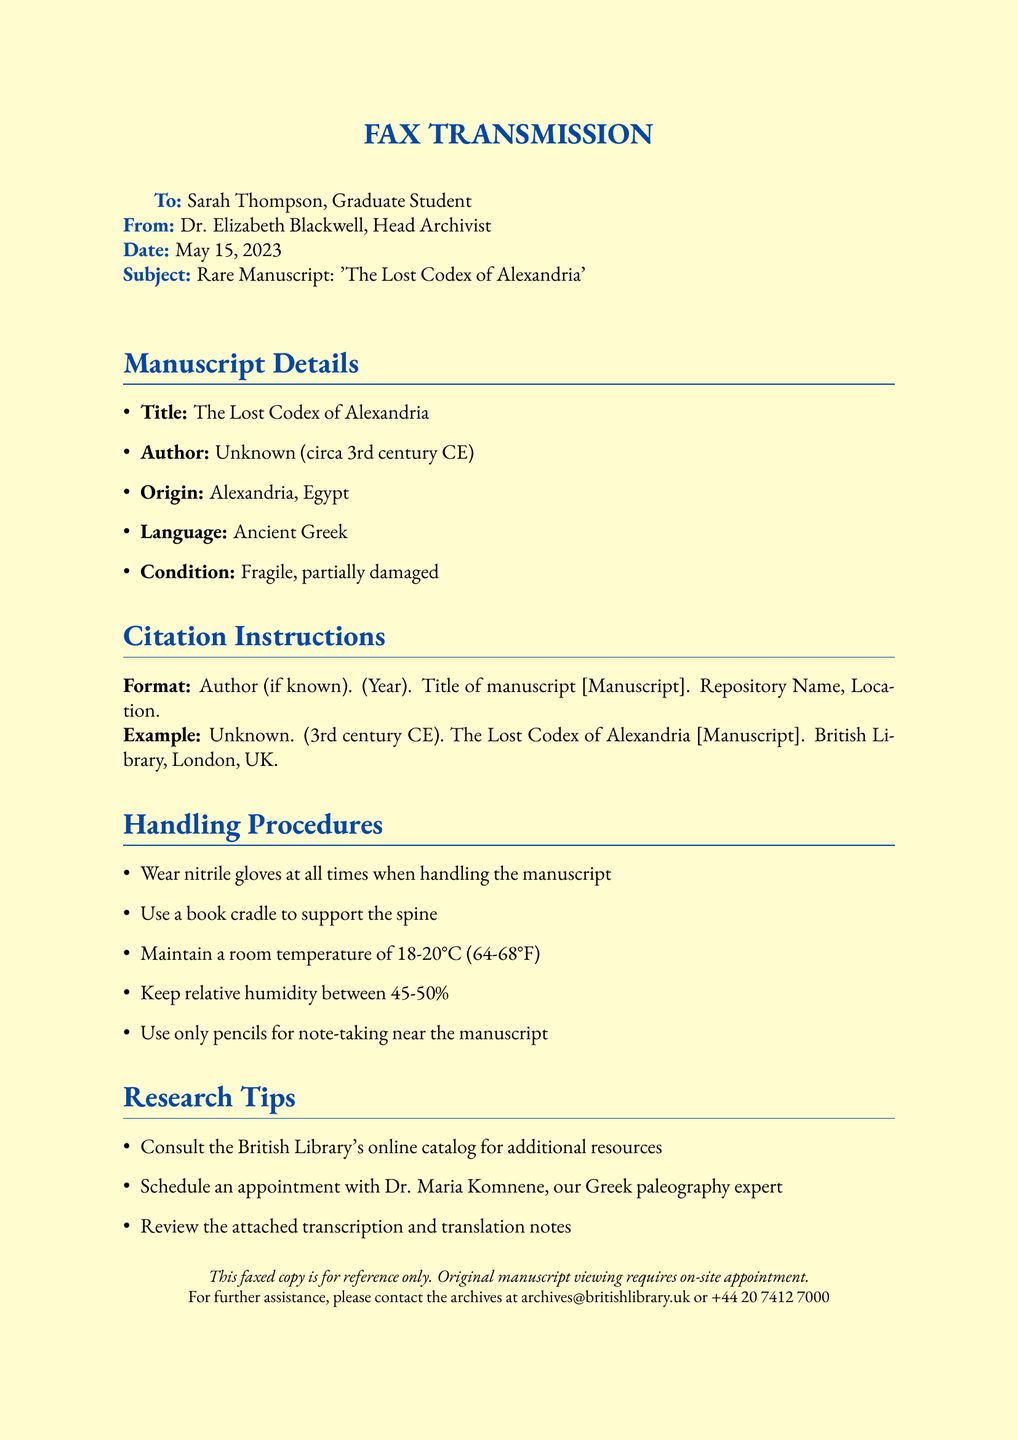What is the title of the manuscript? The title of the manuscript is found in the Manuscript Details section.
Answer: The Lost Codex of Alexandria Who is the author of the manuscript? The author is mentioned in the Manuscript Details section; it specifies that the author is unknown.
Answer: Unknown What is the origin of the manuscript? The origin is listed in the Manuscript Details, specifying the location of creation.
Answer: Alexandria, Egypt What is the handling temperature for the manuscript? The handling procedures provide specific temperature requirements for caring for the manuscript.
Answer: 18-20°C Who should be contacted for further assistance? The footer of the document provides the contact information for assistance with the archives.
Answer: archives@britishlibrary.uk What century is the manuscript believed to be from? The author's date reference in the citation instructions indicates the time period of the manuscript.
Answer: 3rd century CE What type of gloves should be worn when handling the manuscript? The handling procedures specify the type of gloves that need to be used.
Answer: Nitrile gloves What should be used for note-taking near the manuscript? The handling procedures give guidelines on what materials can be used for note-taking.
Answer: Pencils What expert should be consulted for Greek paleography? The research tips section mentions a specific expert to consult for assistance with Greek paleography.
Answer: Dr. Maria Komnene 